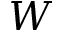<formula> <loc_0><loc_0><loc_500><loc_500>{ W }</formula> 